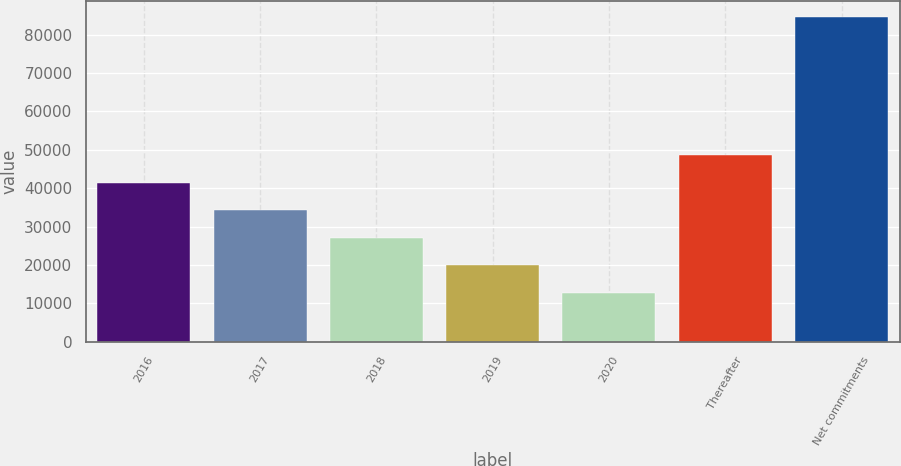Convert chart. <chart><loc_0><loc_0><loc_500><loc_500><bar_chart><fcel>2016<fcel>2017<fcel>2018<fcel>2019<fcel>2020<fcel>Thereafter<fcel>Net commitments<nl><fcel>41465.2<fcel>34298.4<fcel>27131.6<fcel>19964.8<fcel>12798<fcel>48632<fcel>84466<nl></chart> 